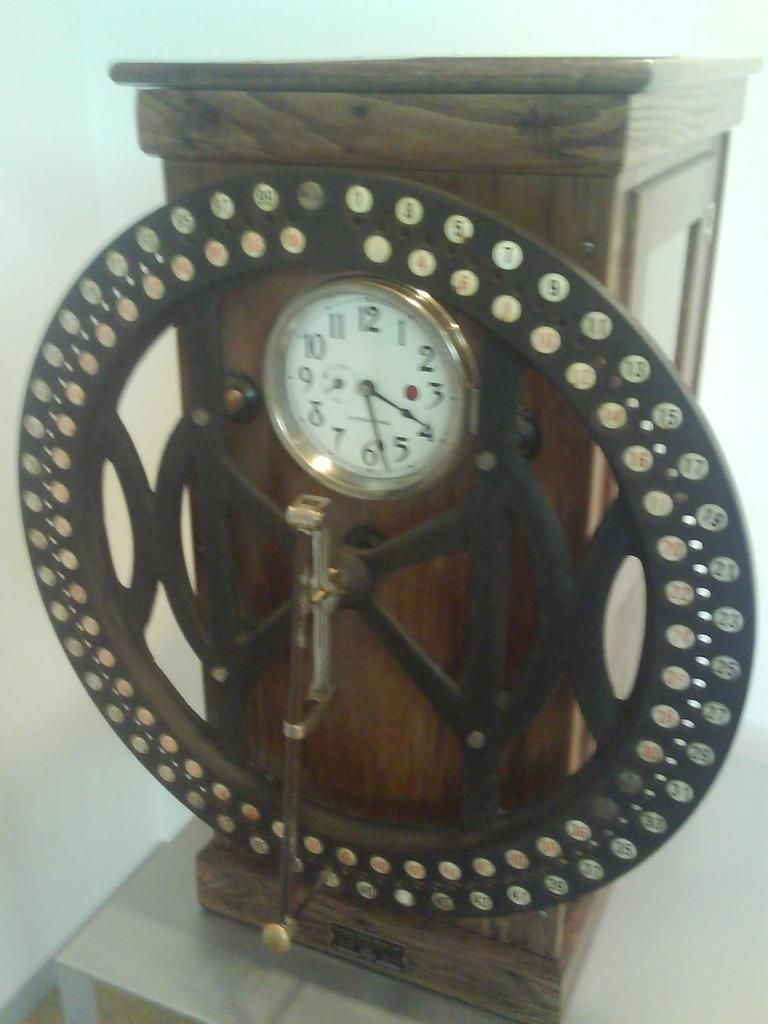<image>
Offer a succinct explanation of the picture presented. an interesting looking clock says that it is 4:28 